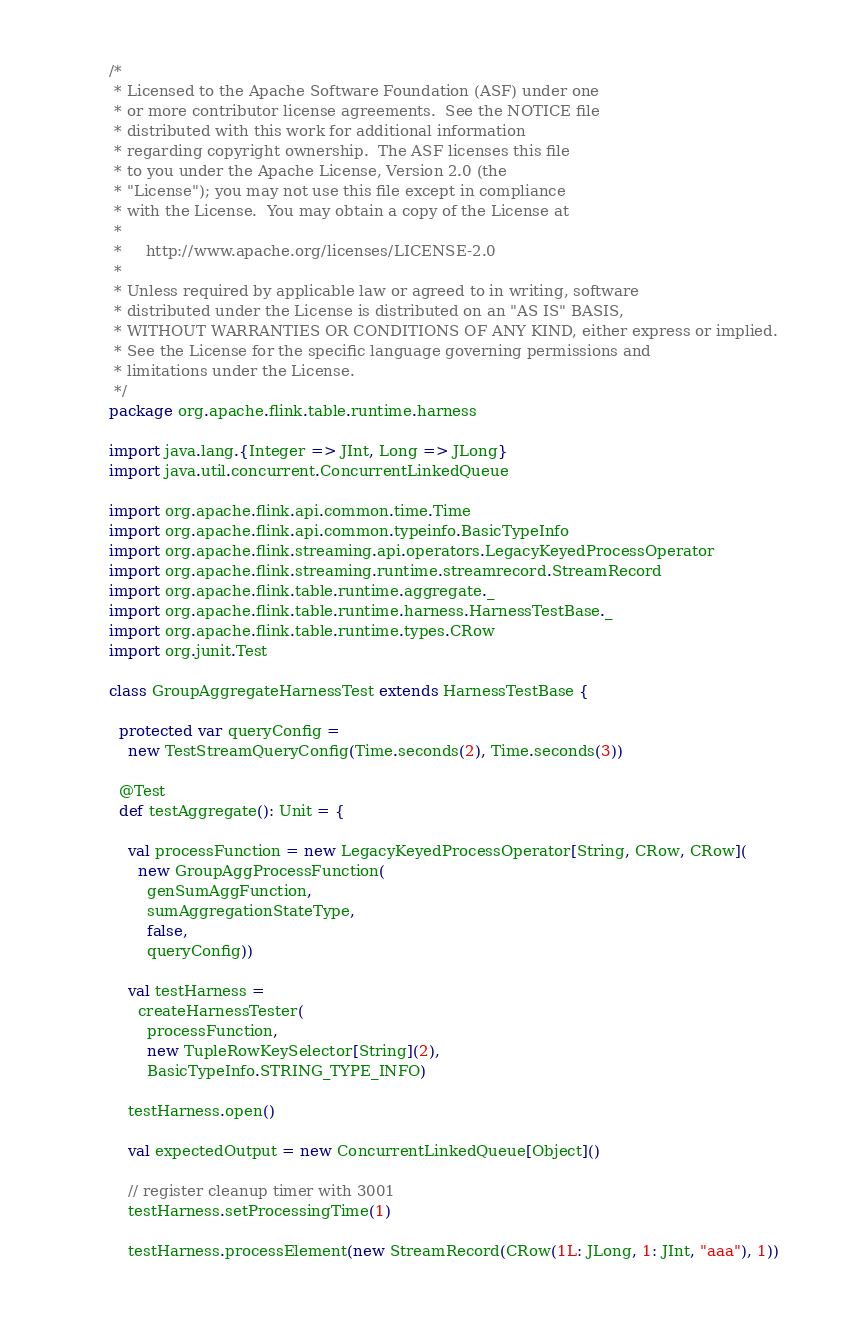<code> <loc_0><loc_0><loc_500><loc_500><_Scala_>/*
 * Licensed to the Apache Software Foundation (ASF) under one
 * or more contributor license agreements.  See the NOTICE file
 * distributed with this work for additional information
 * regarding copyright ownership.  The ASF licenses this file
 * to you under the Apache License, Version 2.0 (the
 * "License"); you may not use this file except in compliance
 * with the License.  You may obtain a copy of the License at
 *
 *     http://www.apache.org/licenses/LICENSE-2.0
 *
 * Unless required by applicable law or agreed to in writing, software
 * distributed under the License is distributed on an "AS IS" BASIS,
 * WITHOUT WARRANTIES OR CONDITIONS OF ANY KIND, either express or implied.
 * See the License for the specific language governing permissions and
 * limitations under the License.
 */
package org.apache.flink.table.runtime.harness

import java.lang.{Integer => JInt, Long => JLong}
import java.util.concurrent.ConcurrentLinkedQueue

import org.apache.flink.api.common.time.Time
import org.apache.flink.api.common.typeinfo.BasicTypeInfo
import org.apache.flink.streaming.api.operators.LegacyKeyedProcessOperator
import org.apache.flink.streaming.runtime.streamrecord.StreamRecord
import org.apache.flink.table.runtime.aggregate._
import org.apache.flink.table.runtime.harness.HarnessTestBase._
import org.apache.flink.table.runtime.types.CRow
import org.junit.Test

class GroupAggregateHarnessTest extends HarnessTestBase {

  protected var queryConfig =
    new TestStreamQueryConfig(Time.seconds(2), Time.seconds(3))

  @Test
  def testAggregate(): Unit = {

    val processFunction = new LegacyKeyedProcessOperator[String, CRow, CRow](
      new GroupAggProcessFunction(
        genSumAggFunction,
        sumAggregationStateType,
        false,
        queryConfig))

    val testHarness =
      createHarnessTester(
        processFunction,
        new TupleRowKeySelector[String](2),
        BasicTypeInfo.STRING_TYPE_INFO)

    testHarness.open()

    val expectedOutput = new ConcurrentLinkedQueue[Object]()

    // register cleanup timer with 3001
    testHarness.setProcessingTime(1)

    testHarness.processElement(new StreamRecord(CRow(1L: JLong, 1: JInt, "aaa"), 1))</code> 